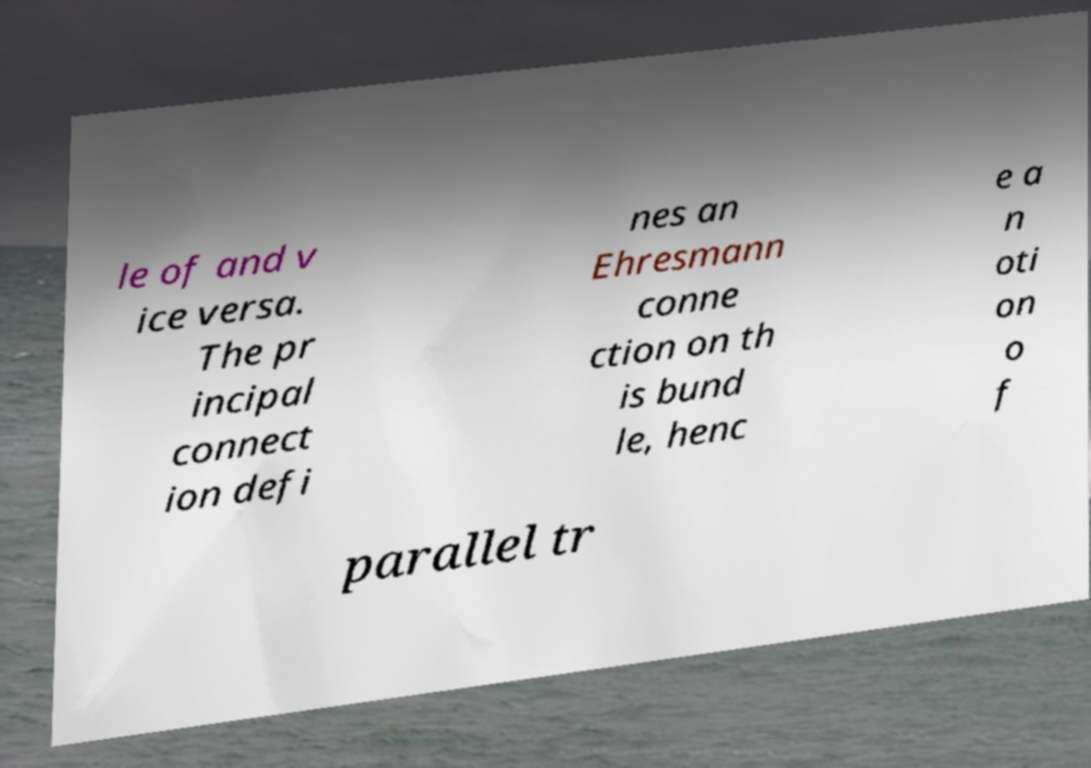For documentation purposes, I need the text within this image transcribed. Could you provide that? le of and v ice versa. The pr incipal connect ion defi nes an Ehresmann conne ction on th is bund le, henc e a n oti on o f parallel tr 